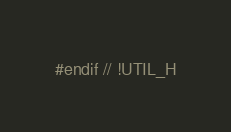<code> <loc_0><loc_0><loc_500><loc_500><_C_>

#endif // !UTIL_H
</code> 